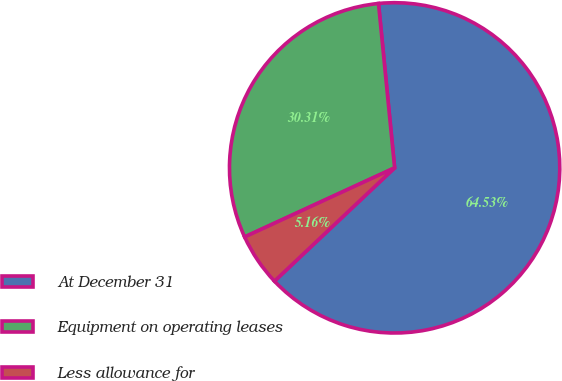<chart> <loc_0><loc_0><loc_500><loc_500><pie_chart><fcel>At December 31<fcel>Equipment on operating leases<fcel>Less allowance for<nl><fcel>64.52%<fcel>30.31%<fcel>5.16%<nl></chart> 